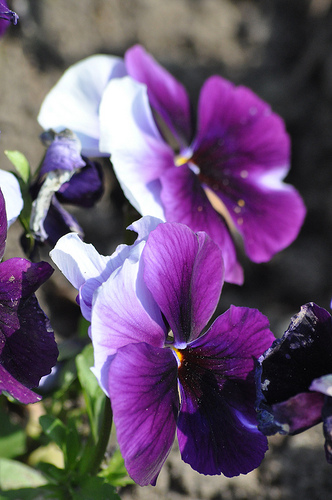<image>
Can you confirm if the flower is on the stem? Yes. Looking at the image, I can see the flower is positioned on top of the stem, with the stem providing support. 